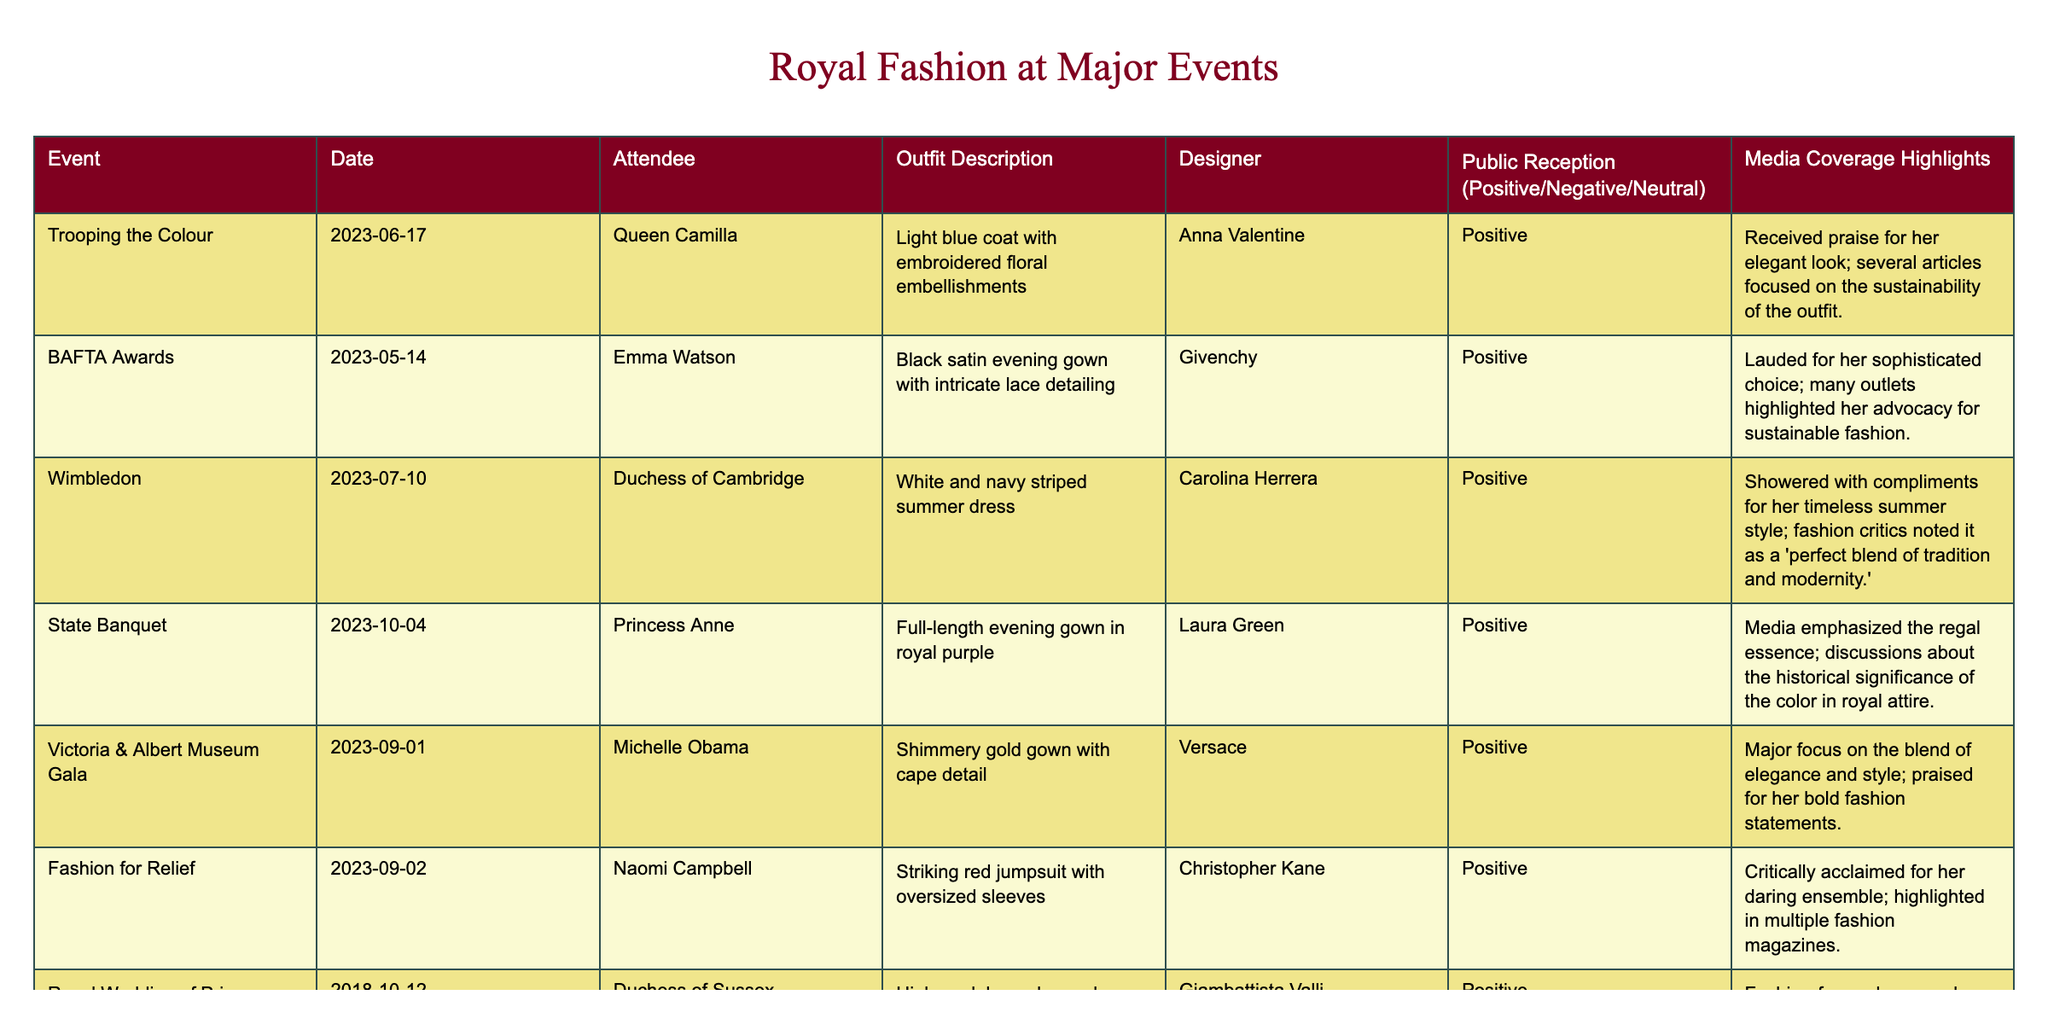What outfit did Queen Camilla wear at Trooping the Colour? The table lists the outfit description for Queen Camilla at Trooping the Colour as a light blue coat with embroidered floral embellishments.
Answer: Light blue coat with embroidered floral embellishments Who designed Emma Watson's outfit at the BAFTA Awards? The table indicates that Emma Watson's outfit was designed by Givenchy, as shown in the designer column for the BAFTA Awards.
Answer: Givenchy How many events had a positive public reception? The table shows that all listed events have a positive public reception. Counting these, there are 7 events.
Answer: 7 Did Princess Anne wear a full-length gown at the State Banquet? According to the table, the outfit description for Princess Anne at the State Banquet is a full-length evening gown in royal purple, which confirms she wore a full-length gown.
Answer: Yes What color was Naomi Campbell's outfit at the Fashion for Relief event? The table states that Naomi Campbell wore a striking red jumpsuit with oversized sleeves. The color red is mentioned directly in the outfit description.
Answer: Red Which designer has the most memorable outfit described in the table, and what event was it worn at? The table indicates that the Duchess of Sussex's outfit at the Royal Wedding of Princess Eugenie, designed by Giambattista Valli, is labeled as one of the most memorable royal looks, suggesting a high profile for this designer at this event.
Answer: Giambattista Valli at the Royal Wedding of Princess Eugenie What event had the most highlighted discussions around sustainable fashion? The BAFTA Awards is highlighted in the table specifically for many outlets focusing on Emma Watson’s advocacy for sustainable fashion, making this event stand out in connection to sustainability.
Answer: BAFTA Awards Which two outfits received the most significant praise for their elegance? By reviewing the public reception details in the table, both Queen Camilla's light blue coat at Trooping the Colour and Michelle Obama's shimmery gold gown at the Victoria & Albert Museum Gala received notable emphasis on elegance.
Answer: Queen Camilla and Michelle Obama What was the common theme across the outfits described in terms of public reception? The public reception columns indicate that all outfits were received positively, highlighting a common theme of approval across the board for royal fashion choices in the listed events.
Answer: Positive reception for all outfits At which event did a royal outfit emphasize historical significance? The table denotes that Princess Anne’s full-length evening gown in royal purple at the State Banquet was emphasized for its regal essence and historical significance related to the color.
Answer: State Banquet Was there any negative public reception for any of the outfits listed? The data shows that all entries in the public reception column indicate a positive or neutral reception, with no negative feedback present for any outfit listed.
Answer: No 